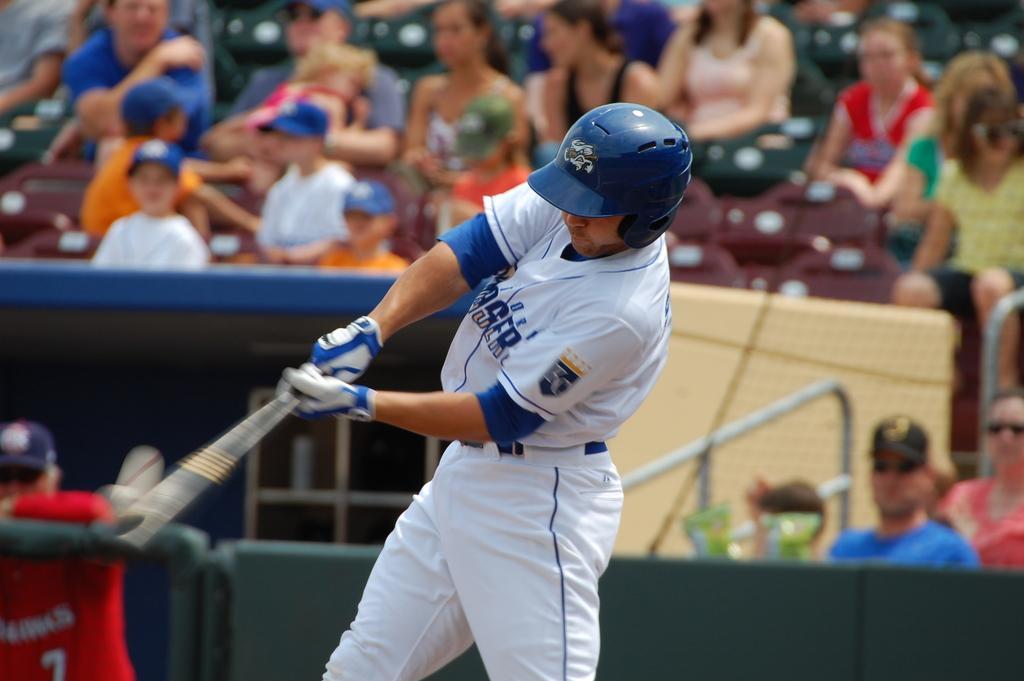Could you give a brief overview of what you see in this image? This picture shows a man playing baseball. He wore a helmet on his head and holding a baseball bat in his hand and hitting the ball and we see audience seated on the chairs and watching and we see few of them wore caps on their heads and couple of them wore sunglasses. He wore gloves to his hands. 